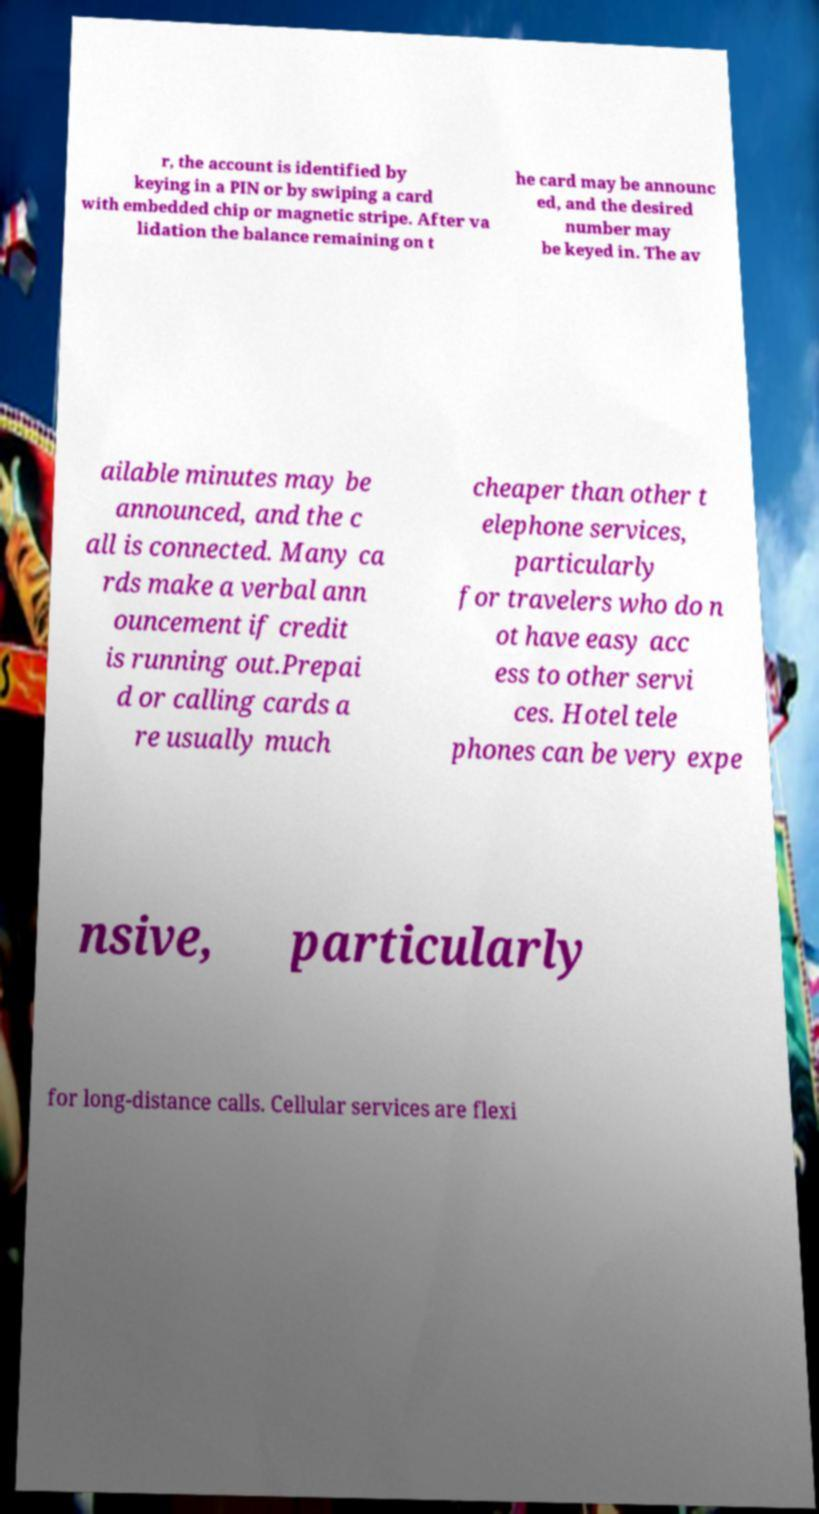Please read and relay the text visible in this image. What does it say? r, the account is identified by keying in a PIN or by swiping a card with embedded chip or magnetic stripe. After va lidation the balance remaining on t he card may be announc ed, and the desired number may be keyed in. The av ailable minutes may be announced, and the c all is connected. Many ca rds make a verbal ann ouncement if credit is running out.Prepai d or calling cards a re usually much cheaper than other t elephone services, particularly for travelers who do n ot have easy acc ess to other servi ces. Hotel tele phones can be very expe nsive, particularly for long-distance calls. Cellular services are flexi 